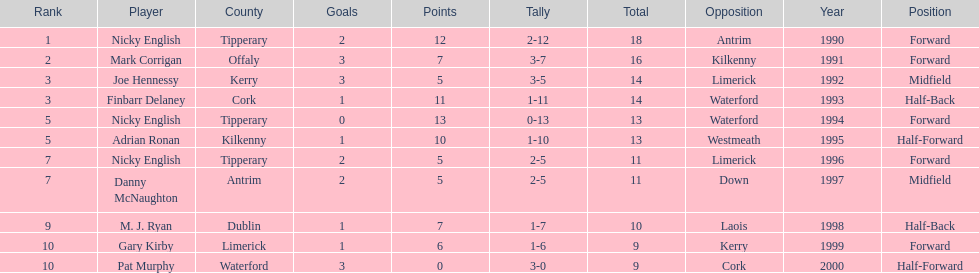What is the least total on the list? 9. 